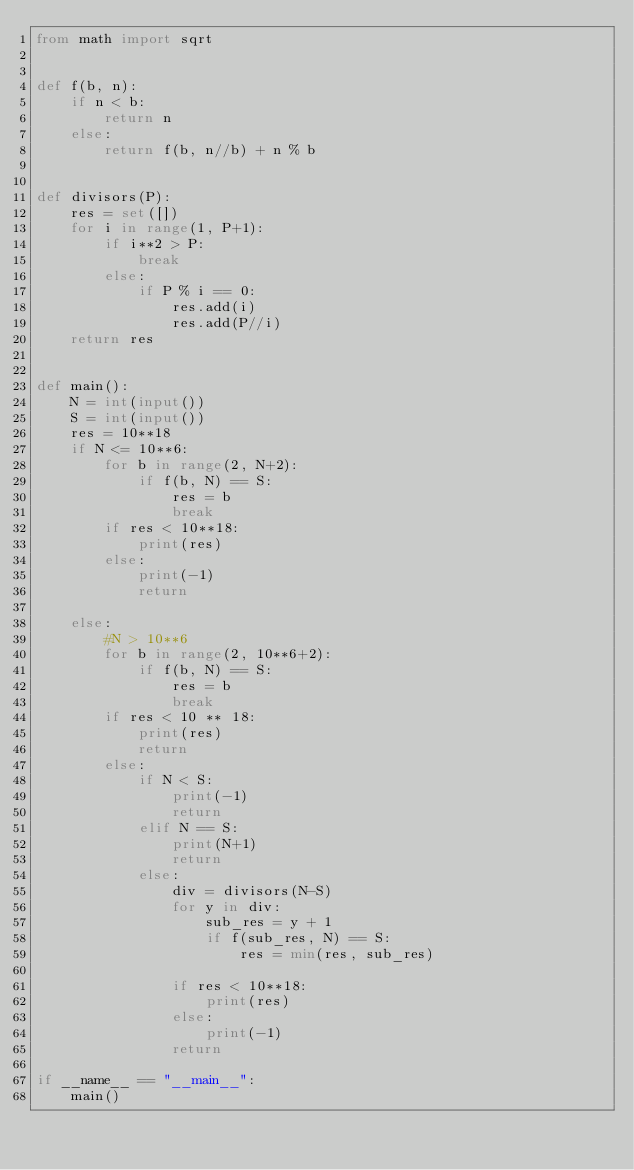Convert code to text. <code><loc_0><loc_0><loc_500><loc_500><_Python_>from math import sqrt


def f(b, n):
    if n < b:
        return n
    else:
        return f(b, n//b) + n % b


def divisors(P):
    res = set([])
    for i in range(1, P+1):
        if i**2 > P:
            break
        else:
            if P % i == 0:
                res.add(i)
                res.add(P//i)
    return res


def main():
    N = int(input())
    S = int(input())
    res = 10**18
    if N <= 10**6:
        for b in range(2, N+2):
            if f(b, N) == S:
                res = b
                break
        if res < 10**18:
            print(res)
        else:
            print(-1)
            return

    else:
        #N > 10**6
        for b in range(2, 10**6+2):
            if f(b, N) == S:
                res = b
                break
        if res < 10 ** 18:
            print(res)
            return
        else:
            if N < S:
                print(-1)
                return
            elif N == S:
                print(N+1)
                return
            else:
                div = divisors(N-S)
                for y in div:
                    sub_res = y + 1
                    if f(sub_res, N) == S:
                        res = min(res, sub_res)
                        
                if res < 10**18:
                    print(res)
                else:
                    print(-1)
                return

if __name__ == "__main__":
    main()
    

</code> 